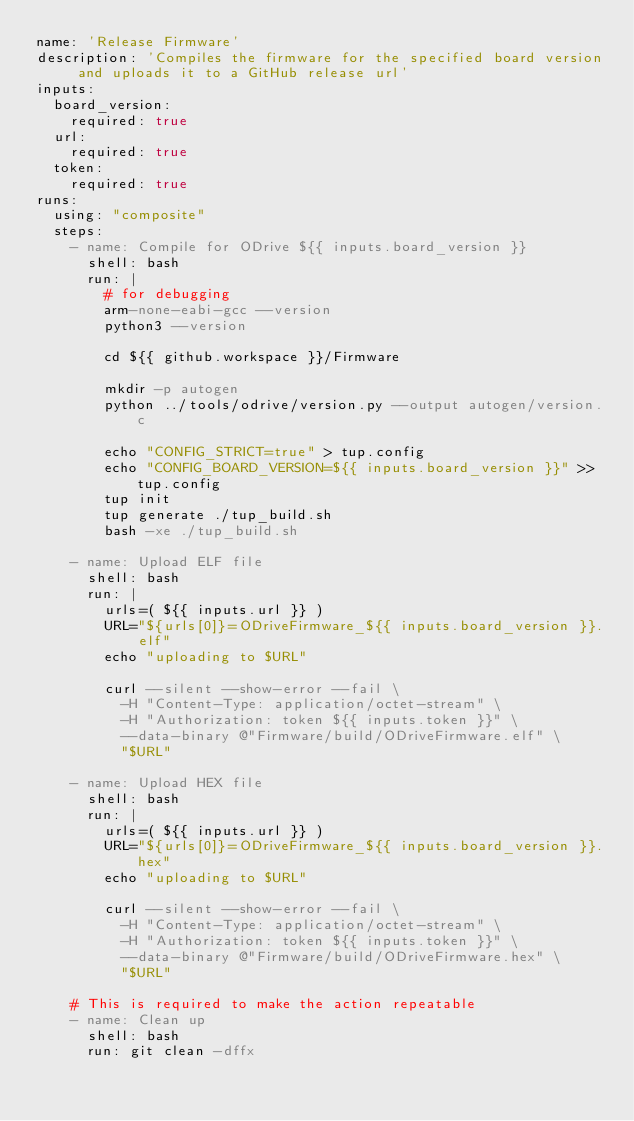<code> <loc_0><loc_0><loc_500><loc_500><_YAML_>name: 'Release Firmware'
description: 'Compiles the firmware for the specified board version and uploads it to a GitHub release url'
inputs:
  board_version:
    required: true
  url:
    required: true
  token:
    required: true
runs:
  using: "composite"
  steps: 
    - name: Compile for ODrive ${{ inputs.board_version }}
      shell: bash
      run: |
        # for debugging
        arm-none-eabi-gcc --version
        python3 --version

        cd ${{ github.workspace }}/Firmware

        mkdir -p autogen
        python ../tools/odrive/version.py --output autogen/version.c

        echo "CONFIG_STRICT=true" > tup.config
        echo "CONFIG_BOARD_VERSION=${{ inputs.board_version }}" >> tup.config
        tup init
        tup generate ./tup_build.sh
        bash -xe ./tup_build.sh
    
    - name: Upload ELF file
      shell: bash
      run: |
        urls=( ${{ inputs.url }} )
        URL="${urls[0]}=ODriveFirmware_${{ inputs.board_version }}.elf"
        echo "uploading to $URL"

        curl --silent --show-error --fail \
          -H "Content-Type: application/octet-stream" \
          -H "Authorization: token ${{ inputs.token }}" \
          --data-binary @"Firmware/build/ODriveFirmware.elf" \
          "$URL"
    
    - name: Upload HEX file
      shell: bash
      run: |
        urls=( ${{ inputs.url }} )
        URL="${urls[0]}=ODriveFirmware_${{ inputs.board_version }}.hex"
        echo "uploading to $URL"
        
        curl --silent --show-error --fail \
          -H "Content-Type: application/octet-stream" \
          -H "Authorization: token ${{ inputs.token }}" \
          --data-binary @"Firmware/build/ODriveFirmware.hex" \
          "$URL"

    # This is required to make the action repeatable
    - name: Clean up
      shell: bash
      run: git clean -dffx
</code> 